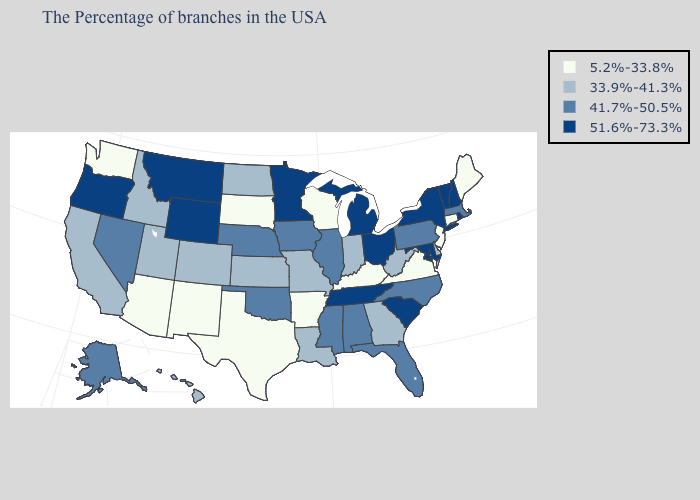Does Arkansas have the lowest value in the South?
Short answer required. Yes. Which states have the lowest value in the South?
Write a very short answer. Virginia, Kentucky, Arkansas, Texas. Name the states that have a value in the range 33.9%-41.3%?
Give a very brief answer. Delaware, West Virginia, Georgia, Indiana, Louisiana, Missouri, Kansas, North Dakota, Colorado, Utah, Idaho, California, Hawaii. Among the states that border New Mexico , does Arizona have the highest value?
Give a very brief answer. No. Which states have the lowest value in the South?
Quick response, please. Virginia, Kentucky, Arkansas, Texas. What is the value of Kentucky?
Answer briefly. 5.2%-33.8%. What is the lowest value in the MidWest?
Quick response, please. 5.2%-33.8%. Name the states that have a value in the range 5.2%-33.8%?
Give a very brief answer. Maine, Connecticut, New Jersey, Virginia, Kentucky, Wisconsin, Arkansas, Texas, South Dakota, New Mexico, Arizona, Washington. Does the map have missing data?
Keep it brief. No. Name the states that have a value in the range 5.2%-33.8%?
Keep it brief. Maine, Connecticut, New Jersey, Virginia, Kentucky, Wisconsin, Arkansas, Texas, South Dakota, New Mexico, Arizona, Washington. What is the value of Maine?
Be succinct. 5.2%-33.8%. Does Maryland have the highest value in the USA?
Short answer required. Yes. What is the highest value in the USA?
Short answer required. 51.6%-73.3%. Which states have the highest value in the USA?
Concise answer only. Rhode Island, New Hampshire, Vermont, New York, Maryland, South Carolina, Ohio, Michigan, Tennessee, Minnesota, Wyoming, Montana, Oregon. What is the value of Florida?
Keep it brief. 41.7%-50.5%. 